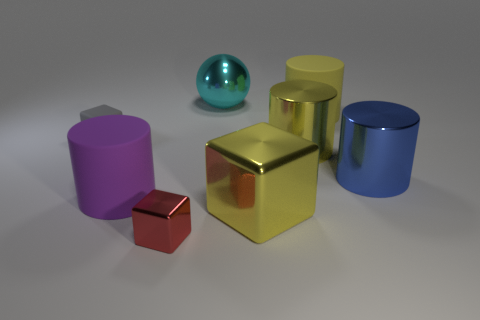What number of yellow things have the same material as the large blue object?
Offer a terse response. 2. There is a cylinder behind the tiny thing to the left of the big thing to the left of the cyan metal object; what is its size?
Keep it short and to the point. Large. There is a blue shiny object; how many big yellow shiny cylinders are on the left side of it?
Offer a terse response. 1. Are there more small objects than cyan spheres?
Offer a terse response. Yes. What is the size of the matte cylinder that is the same color as the large cube?
Provide a succinct answer. Large. There is a matte object that is to the left of the large metallic sphere and right of the small rubber block; what is its size?
Your answer should be very brief. Large. There is a big yellow cylinder right of the large yellow cylinder in front of the large matte cylinder behind the large purple thing; what is its material?
Ensure brevity in your answer.  Rubber. Is the color of the big shiny cylinder that is behind the blue metallic thing the same as the matte cylinder right of the metal ball?
Offer a very short reply. Yes. There is a large rubber object that is left of the small cube that is in front of the rubber object that is left of the purple rubber cylinder; what shape is it?
Your answer should be very brief. Cylinder. There is a shiny thing that is both in front of the blue cylinder and right of the big cyan sphere; what shape is it?
Keep it short and to the point. Cube. 